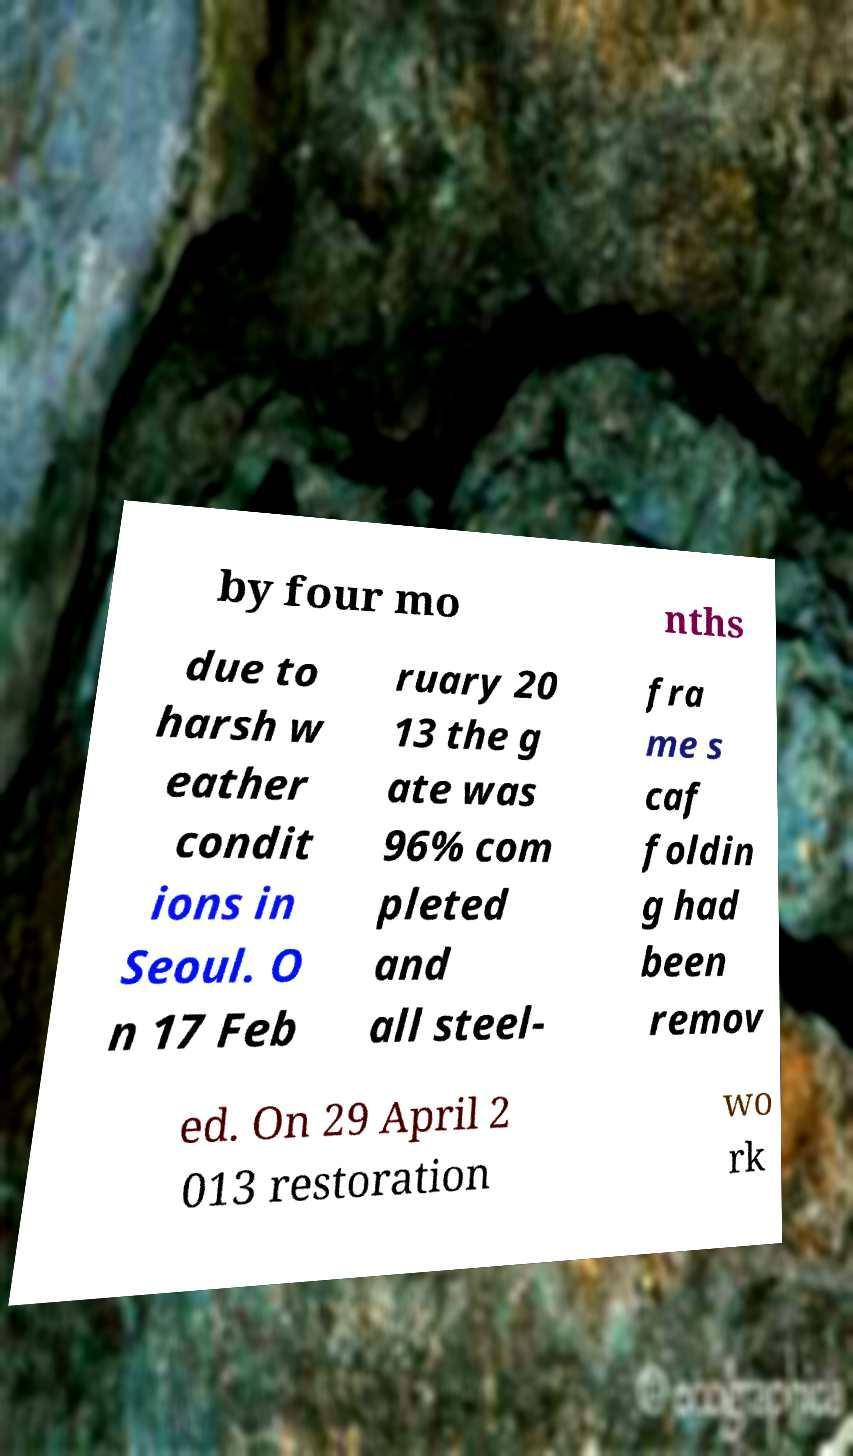Please identify and transcribe the text found in this image. by four mo nths due to harsh w eather condit ions in Seoul. O n 17 Feb ruary 20 13 the g ate was 96% com pleted and all steel- fra me s caf foldin g had been remov ed. On 29 April 2 013 restoration wo rk 